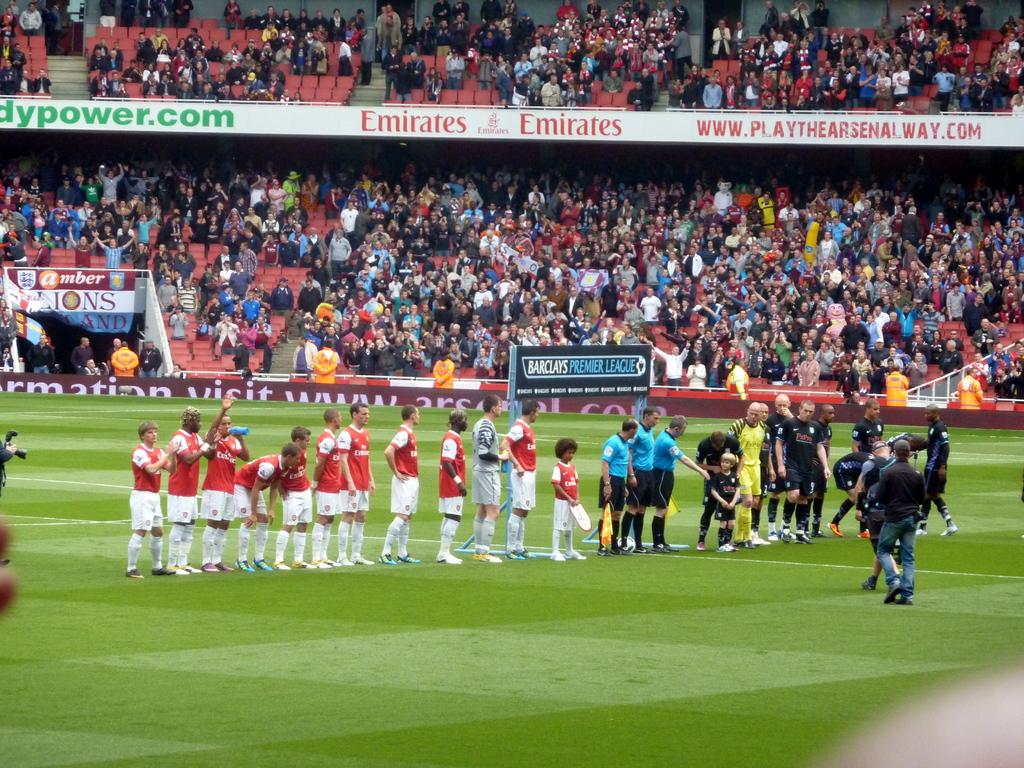What are some of the sponsors of this soccer match?
Provide a short and direct response. Emirates. What team is playing?
Provide a succinct answer. Arsenal. 